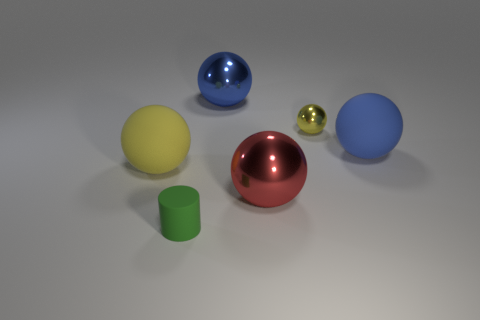Are there any things that have the same material as the cylinder?
Your response must be concise. Yes. What material is the yellow ball that is the same size as the green object?
Make the answer very short. Metal. What number of other large matte things are the same shape as the big yellow object?
Offer a very short reply. 1. What size is the yellow ball that is made of the same material as the red sphere?
Make the answer very short. Small. There is a sphere that is to the right of the large yellow object and left of the red sphere; what material is it made of?
Your response must be concise. Metal. What number of other red balls have the same size as the red sphere?
Your answer should be very brief. 0. There is another yellow object that is the same shape as the tiny yellow object; what material is it?
Your answer should be compact. Rubber. What number of objects are either yellow balls that are to the left of the tiny rubber object or big yellow objects that are on the left side of the small metallic object?
Ensure brevity in your answer.  1. There is a tiny shiny thing; is it the same shape as the large matte thing that is in front of the big blue matte sphere?
Provide a short and direct response. Yes. What shape is the rubber object that is in front of the large metallic object in front of the blue ball that is on the right side of the large red metal ball?
Give a very brief answer. Cylinder. 